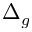<formula> <loc_0><loc_0><loc_500><loc_500>\Delta _ { g }</formula> 